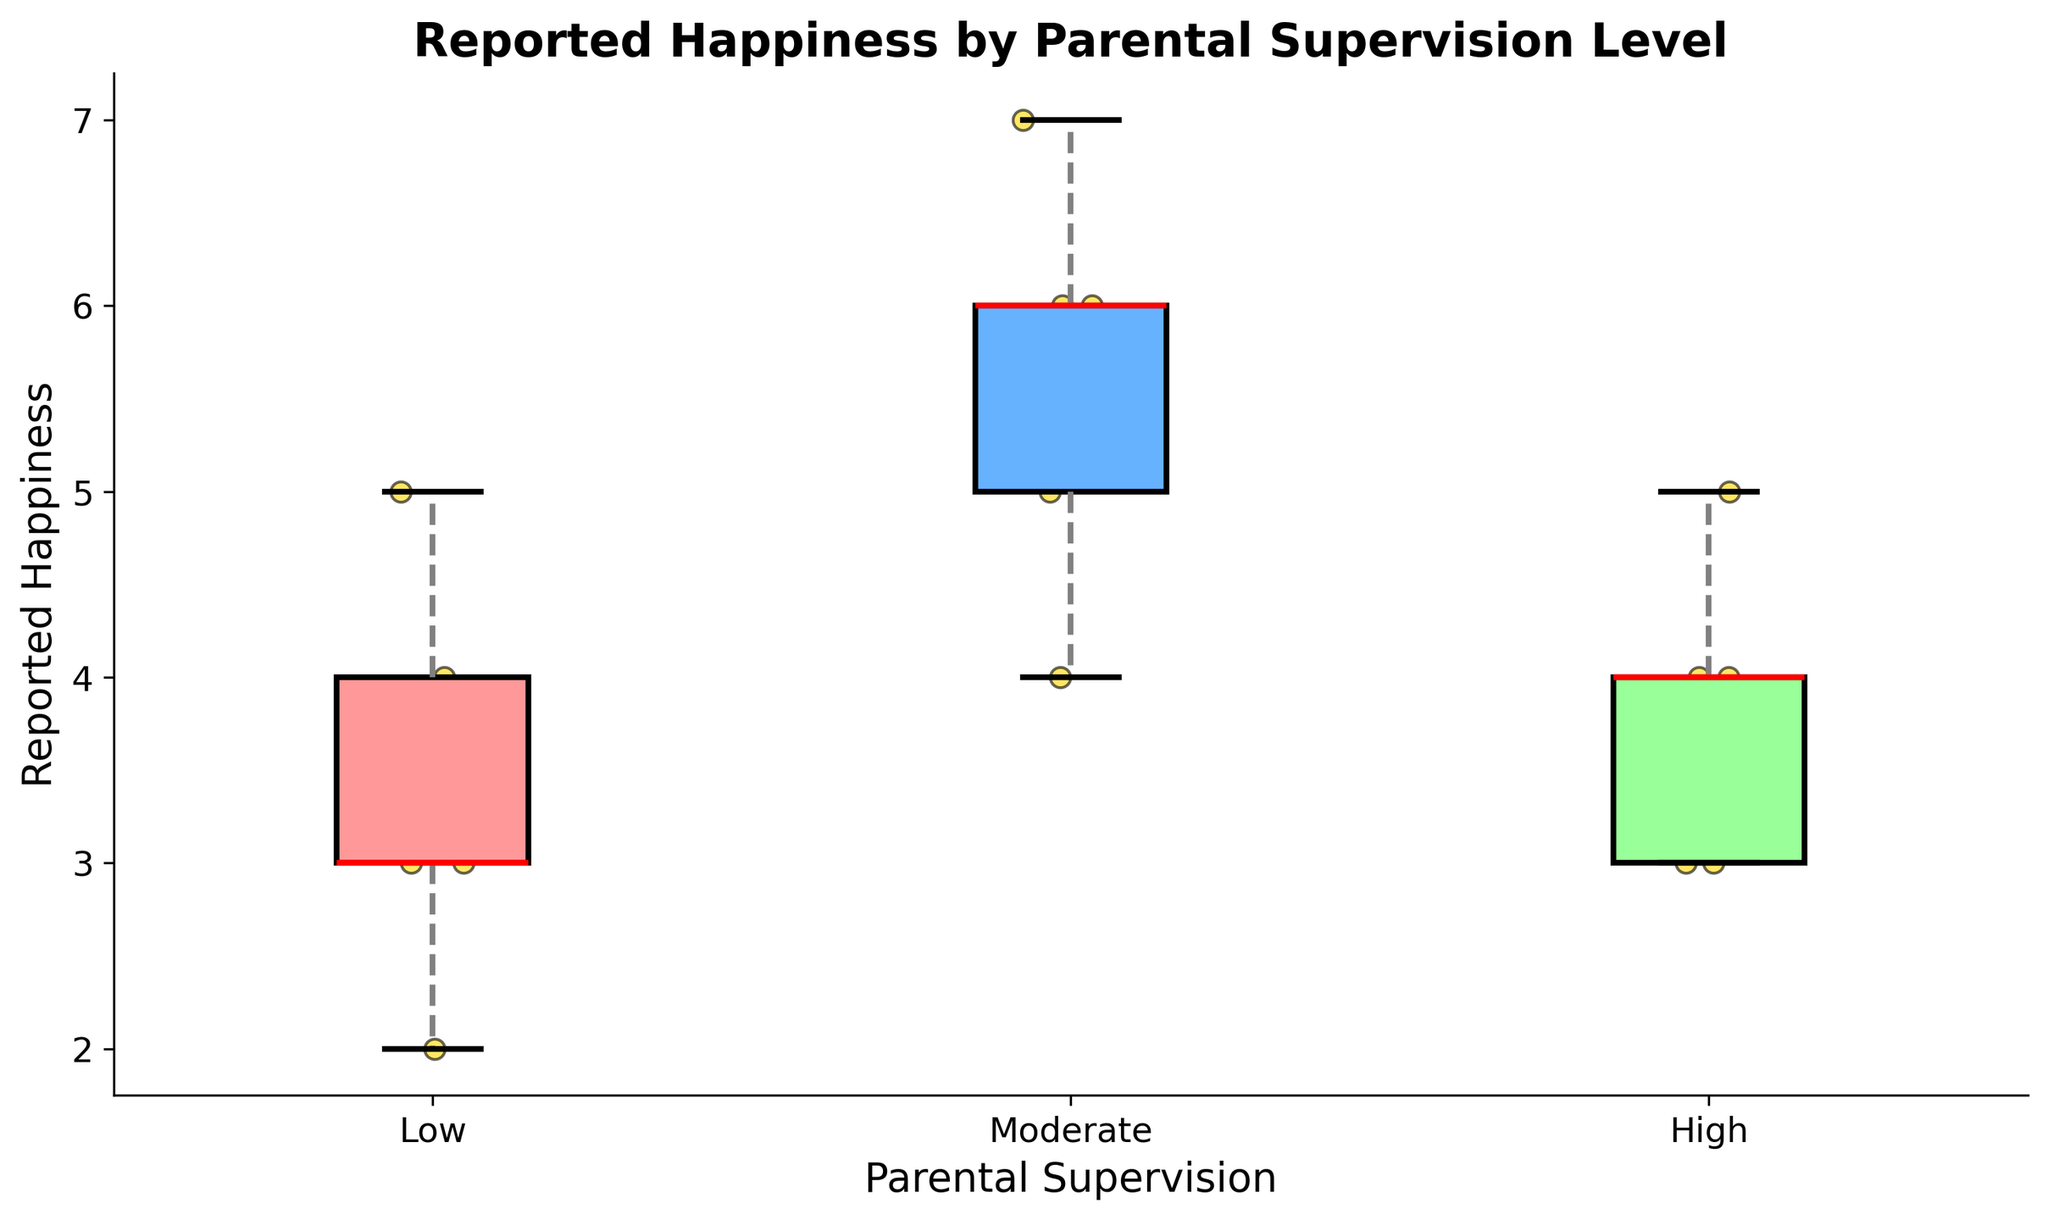What's the title of the plot? The title of the plot is usually the text at the top of the figure. It provides a summary of what the figure is about. In this case, the title is "Reported Happiness by Parental Supervision Level" because that summarizes the content and purpose of the figure.
Answer: Reported Happiness by Parental Supervision Level What are the three categories of parental supervision presented in the plot? The categories of parental supervision are represented along the x-axis. In this plot, they are "Low," "Moderate," and "High."
Answer: Low, Moderate, High What is the median reported happiness for the 'High' parental supervision group? The median is indicated by the red line within the box for each category. For the 'High' parental supervision group, the red line appears at happiness level 4.
Answer: 4 Which group shows the highest median reported happiness? The median reported happiness is observed via the red line in each box plot. The 'Moderate' parental supervision group has the highest median, which is 6.
Answer: Moderate What are the whisker values (minimum and maximum) for the 'Low' parental supervision category? The whiskers extend from the box to the smallest and largest data points not considered outliers. For the 'Low' category, the whiskers extend from 2 to 5.
Answer: 2, 5 How does the spread of reported happiness for the 'Moderate' group compare to the 'High' group? The spread is observed by looking at the range of the box and whiskers. The 'Moderate' group has a wider spread, from 4 to 7, while the 'High' group ranges from 3 to 5.
Answer: Moderate group has a wider spread Which category has the most consistent (least variable) reported happiness scores? Consistency or variability is indicated by the range of the box and whiskers. The 'High' category appears the most consistent, with the smallest range of values (3 to 5).
Answer: High Are there any outliers in the reported happiness scores for any group? Outliers would typically be indicated by individual points outside the whiskers, but there appear to be none marked in this plot.
Answer: No What color are the scatter points in the plot? The scatter points are colored in gold, which adds contrast to the other colors used in the box plots.
Answer: Gold How many data points are there in the 'Low' parental supervision category? By counting the individual scatter points in the 'Low' category, we see there are five data points.
Answer: 5 